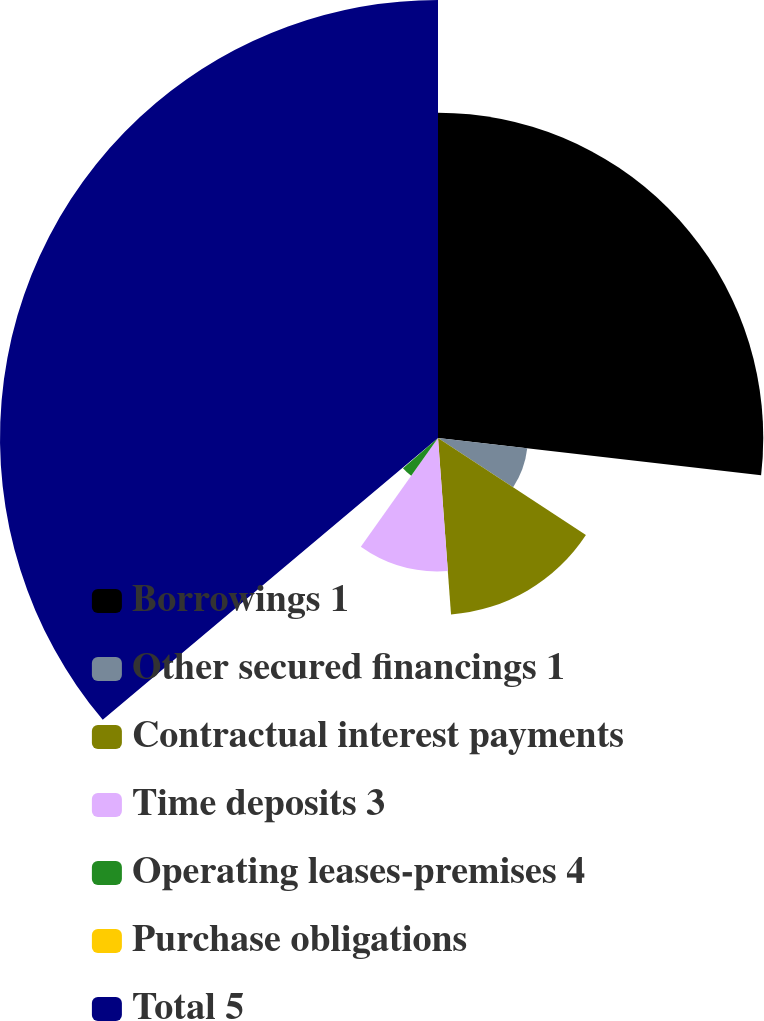Convert chart to OTSL. <chart><loc_0><loc_0><loc_500><loc_500><pie_chart><fcel>Borrowings 1<fcel>Other secured financings 1<fcel>Contractual interest payments<fcel>Time deposits 3<fcel>Operating leases-premises 4<fcel>Purchase obligations<fcel>Total 5<nl><fcel>26.83%<fcel>7.41%<fcel>14.59%<fcel>11.0%<fcel>3.82%<fcel>0.23%<fcel>36.13%<nl></chart> 